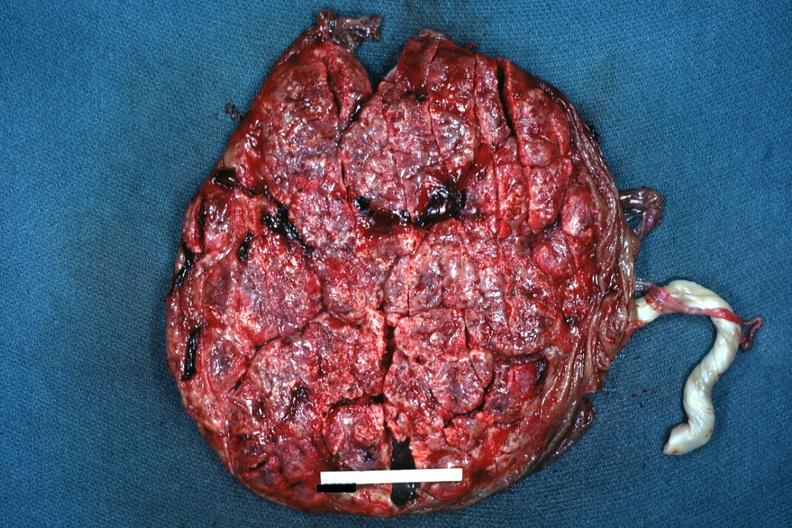where does this belong to?
Answer the question using a single word or phrase. Female reproductive system 